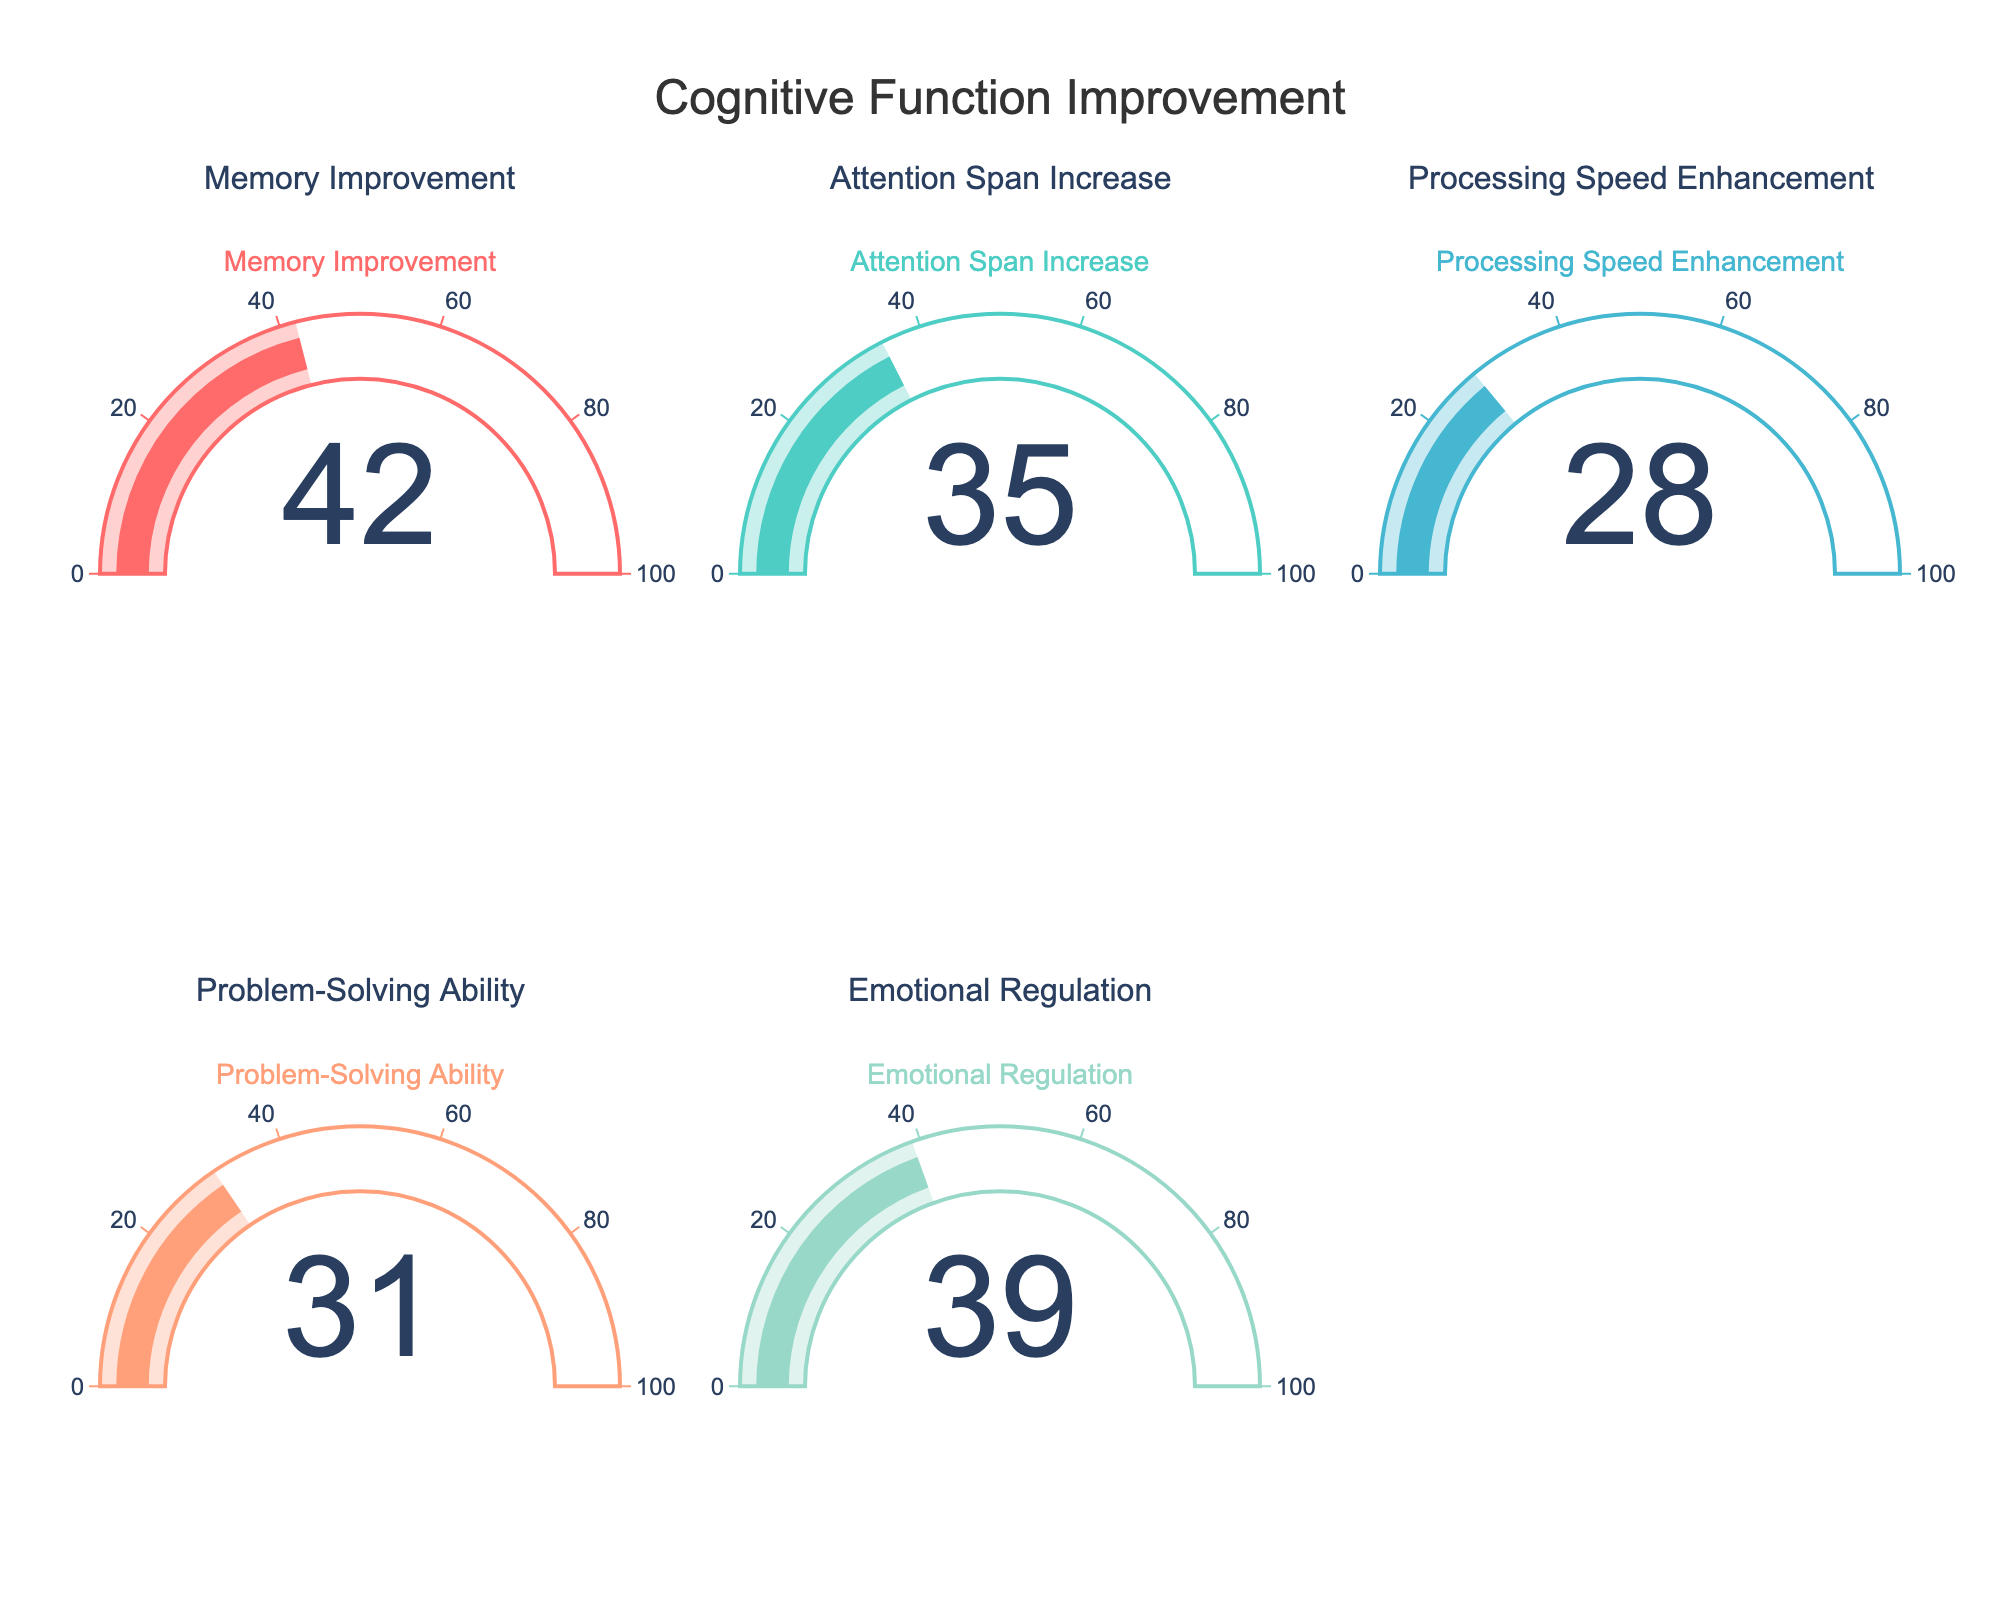What is the total percentage improvement for all cognitive functions combined? To find the total percentage improvement, we sum the values of all the cognitive functions: Memory Improvement (42) + Attention Span Increase (35) + Processing Speed Enhancement (28) + Problem-Solving Ability (31) + Emotional Regulation (39). The total is 42 + 35 + 28 + 31 + 39 = 175.
Answer: 175 Which cognitive function showed the highest improvement percentage? We compare the values of all cognitive functions to identify the highest one. The values are Memory Improvement (42), Attention Span Increase (35), Processing Speed Enhancement (28), Problem-Solving Ability (31), Emotional Regulation (39). The highest value is for Memory Improvement.
Answer: Memory Improvement Which cognitive function showed the lowest improvement percentage? We compare the values of all cognitive functions to identify the lowest one. The values are Memory Improvement (42), Attention Span Increase (35), Processing Speed Enhancement (28), Problem-Solving Ability (31), Emotional Regulation (39). The lowest value is for Processing Speed Enhancement.
Answer: Processing Speed Enhancement How much greater is the Memory Improvement percentage compared to the Attention Span Increase percentage? We subtract the Attention Span Increase value from the Memory Improvement value: Memory Improvement (42) - Attention Span Increase (35). The difference is 42 - 35 = 7.
Answer: 7 What is the average improvement percentage across all cognitive functions? To find the average, we first find the total improvement which is 175 (as calculated previously). Then we divide by the number of cognitive functions: 175 / 5. The average is 35.
Answer: 35 Is the improvement in Emotional Regulation greater than the improvement in Problem-Solving Ability? We compare the values for Emotional Regulation and Problem-Solving Ability: Emotional Regulation (39) and Problem-Solving Ability (31). Since 39 > 31, yes, it is greater.
Answer: Yes What is the sum of improvement percentages for Processing Speed Enhancement and Emotional Regulation? We add the values of Processing Speed Enhancement and Emotional Regulation: Processing Speed Enhancement (28) + Emotional Regulation (39). The total is 28 + 39 = 67.
Answer: 67 Which cognitive function showed an improvement percentage between 30 and 40? We look at the values to find any that fall within the range of 30 to 40: Attention Span Increase (35), Problem-Solving Ability (31), and Emotional Regulation (39). These three fall within the specified range.
Answer: Attention Span Increase, Problem-Solving Ability, Emotional Regulation How many cognitive functions show an improvement percentage above 30? We check the values: Memory Improvement (42), Attention Span Increase (35), Processing Speed Enhancement (28), Problem-Solving Ability (31), Emotional Regulation (39). Four values are above 30: 42, 35, 31, and 39.
Answer: 4 